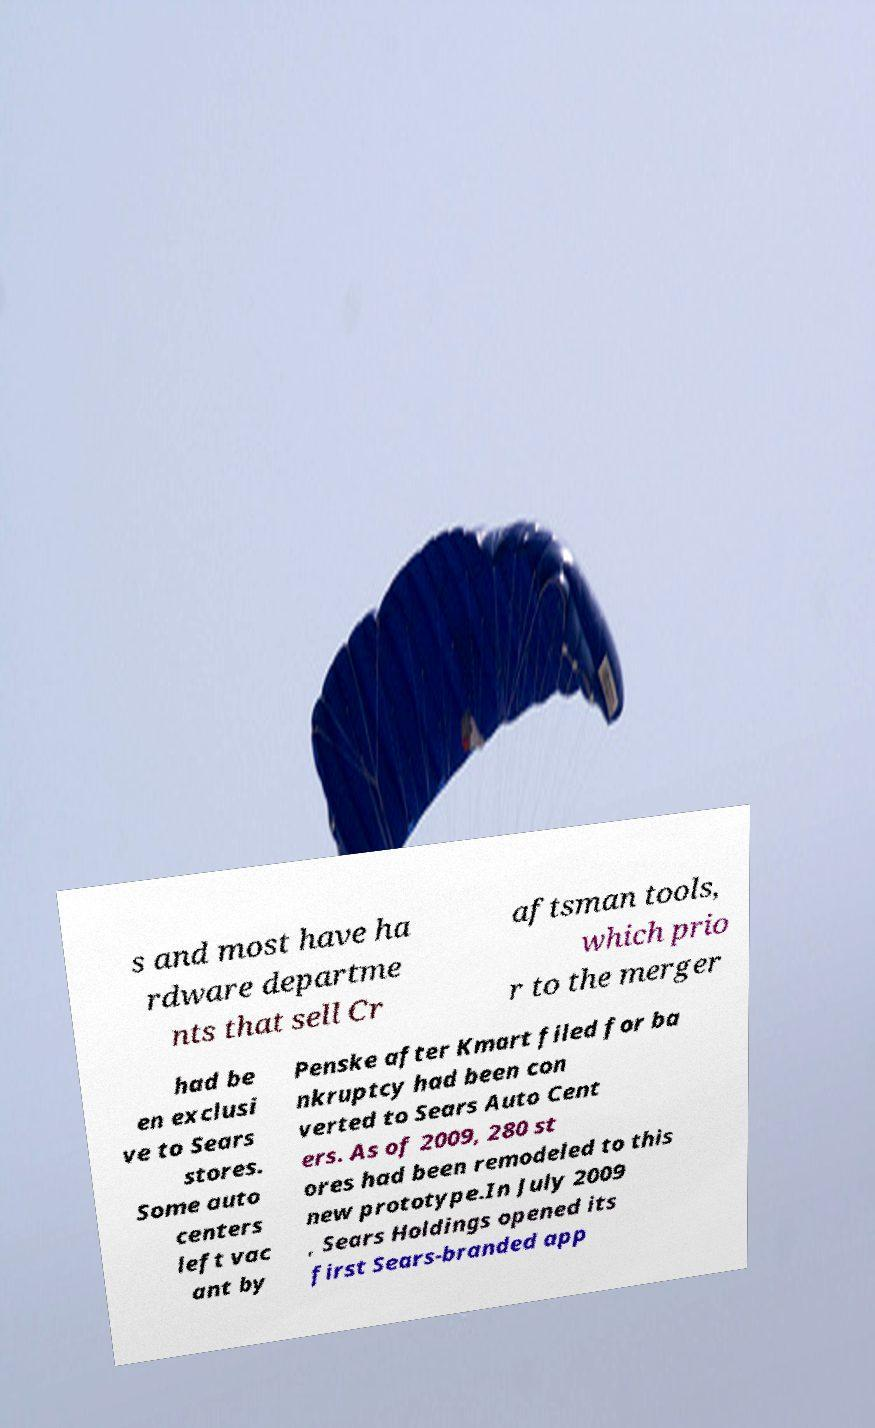Please read and relay the text visible in this image. What does it say? s and most have ha rdware departme nts that sell Cr aftsman tools, which prio r to the merger had be en exclusi ve to Sears stores. Some auto centers left vac ant by Penske after Kmart filed for ba nkruptcy had been con verted to Sears Auto Cent ers. As of 2009, 280 st ores had been remodeled to this new prototype.In July 2009 , Sears Holdings opened its first Sears-branded app 